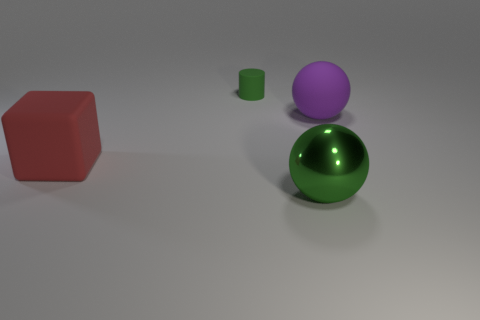What might the different colors of the objects suggest? The variety of colors in the objects might be used to distinguish them from one another or could suggest a playful or artistic arrangement, as if they are part of a color study or a visual composition exploring shapes and hues. 